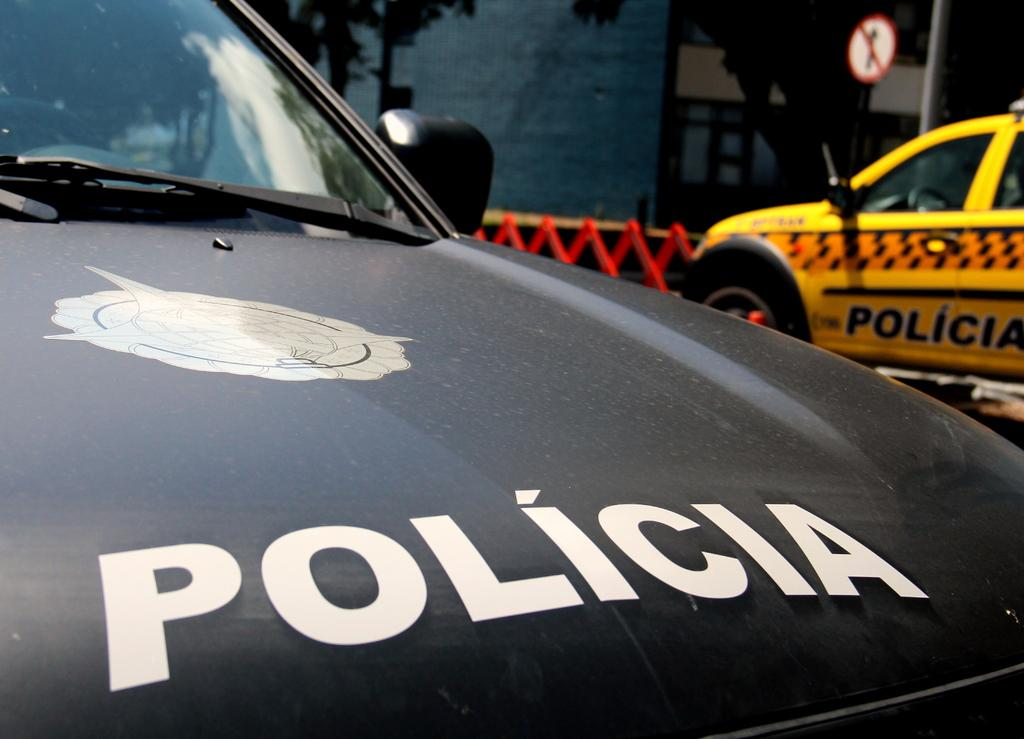<image>
Describe the image concisely. Parked black police car with the word "Policia" on the hood. 